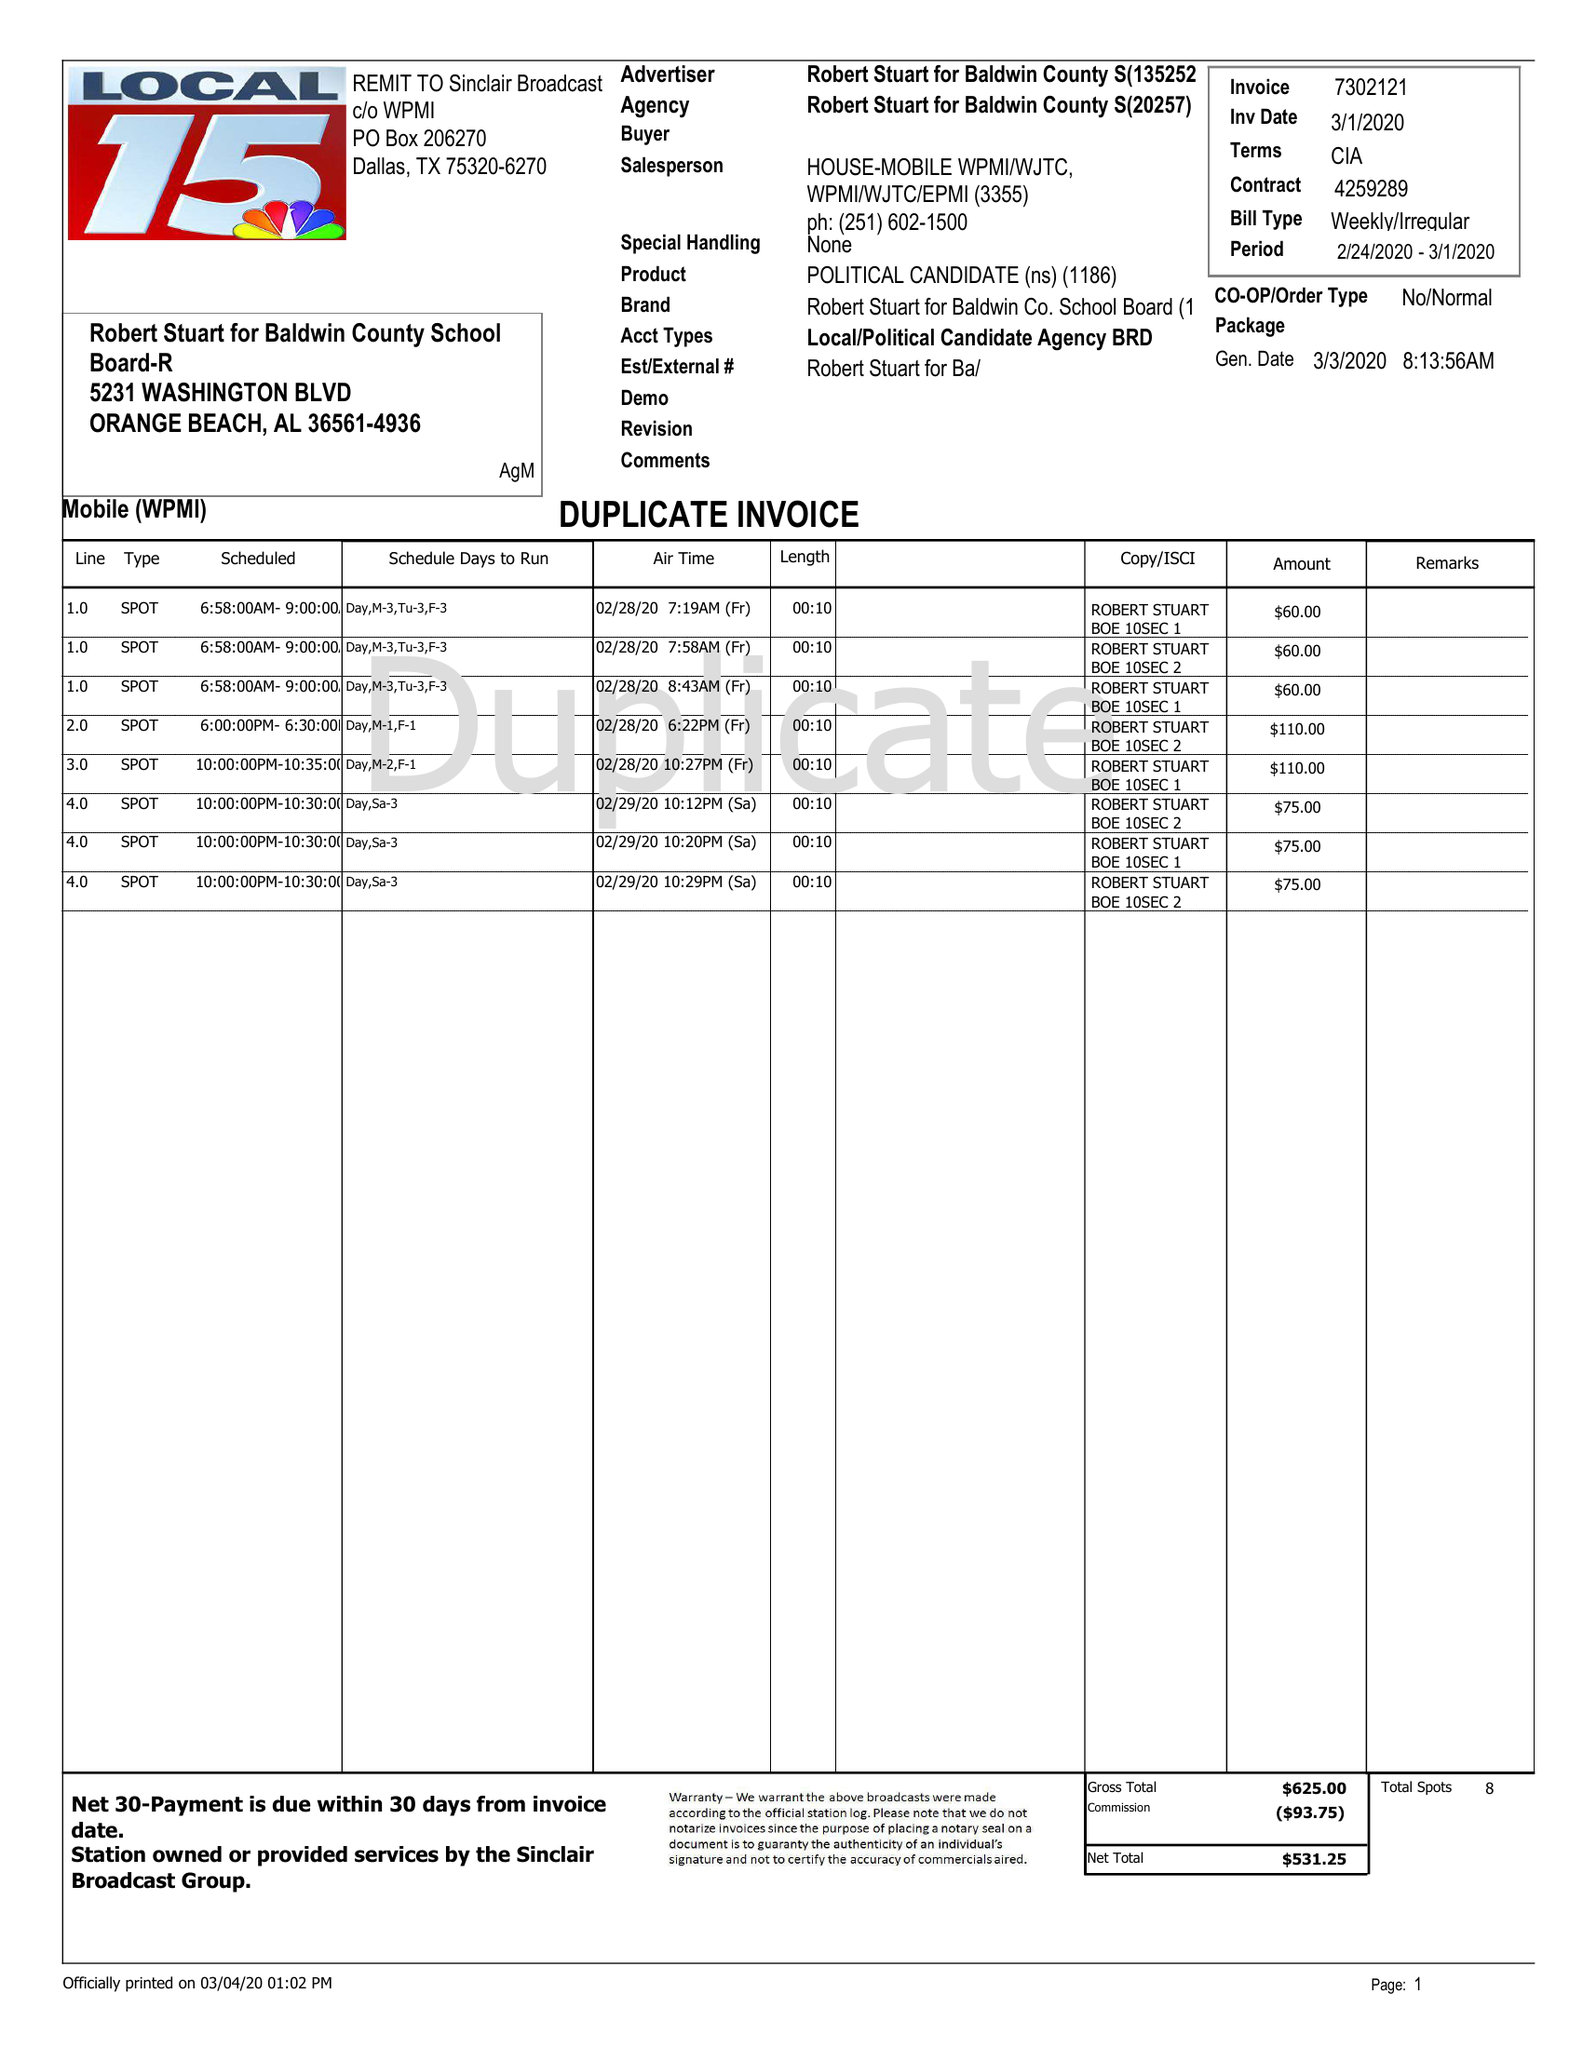What is the value for the flight_from?
Answer the question using a single word or phrase. 02/24/20 